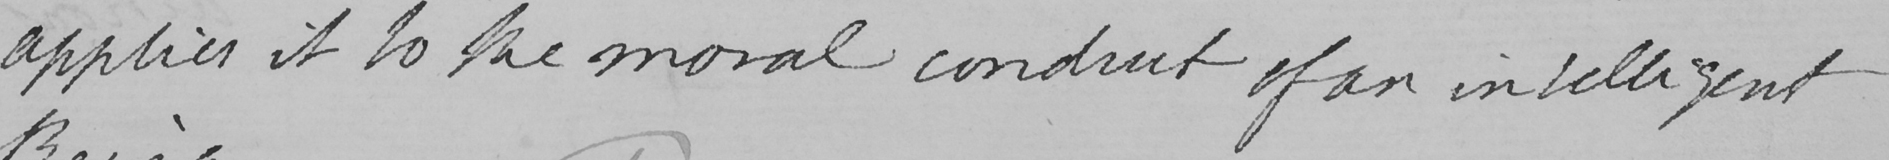What does this handwritten line say? applies it to the moral conduct of an intelligent 